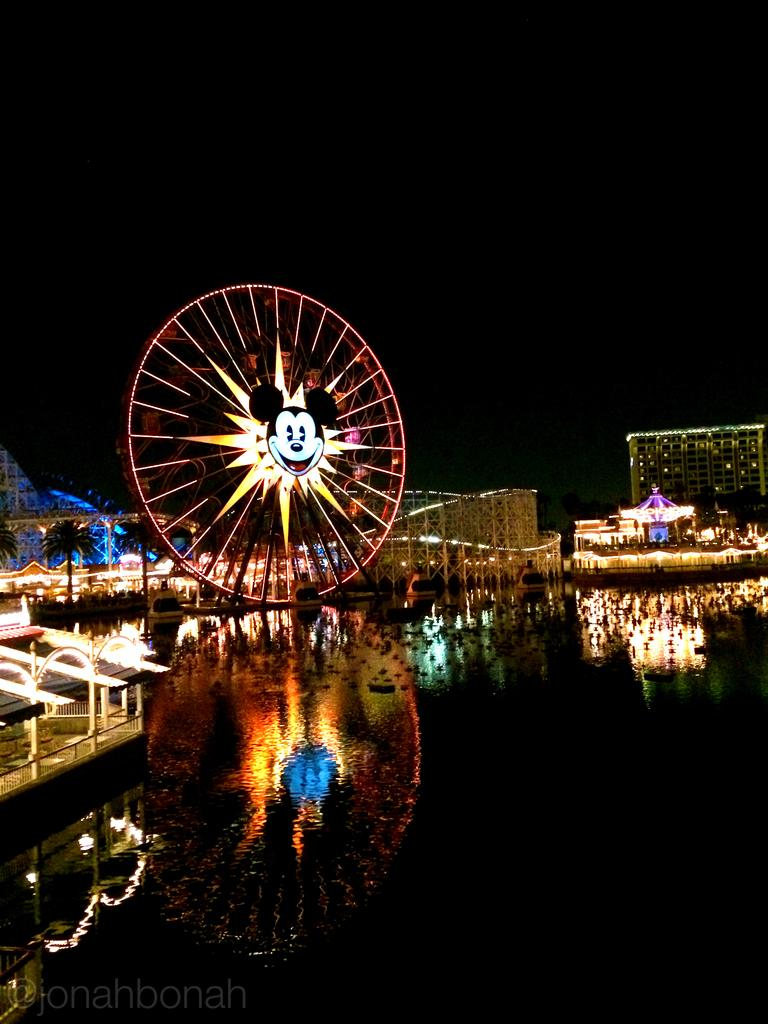What is the main feature of the image? The main feature of the image is a Ferris wheel. What else can be seen in the image besides the Ferris wheel? There is water, buildings, amusement park rides, trees, and the sky visible in the image. What type of environment is depicted in the image? The image depicts an amusement park or fairground setting. Can you describe the sky in the image? The sky is visible in the background of the image. How many babies are present in the image? There are no babies present in the image. What type of crime is being committed in the image? There is no crime depicted in the image. 